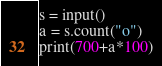Convert code to text. <code><loc_0><loc_0><loc_500><loc_500><_Python_>s = input()
a = s.count("o")
print(700+a*100)</code> 